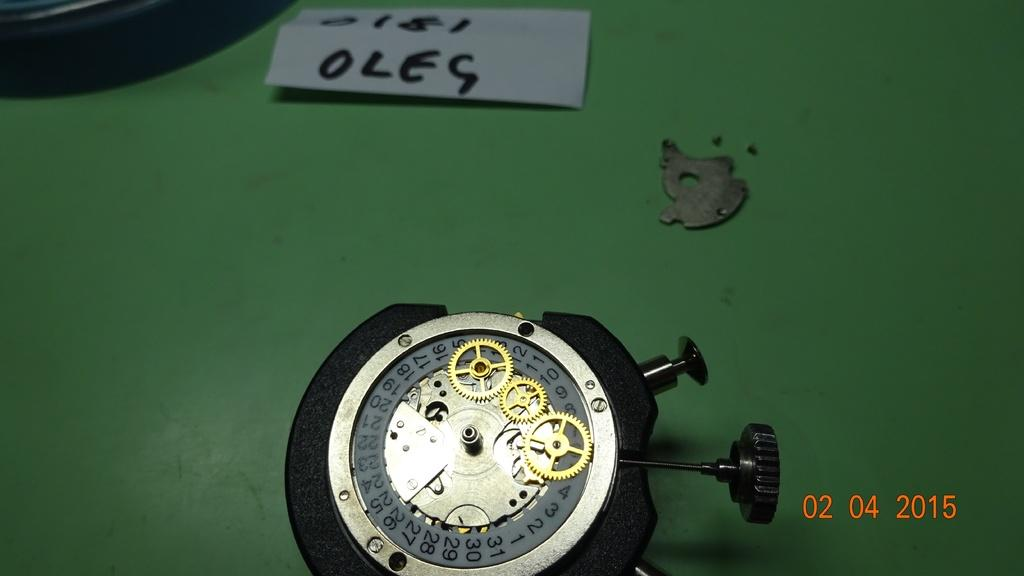<image>
Write a terse but informative summary of the picture. The inside, mechanics of a watch were photographed on April 2, 2015. 